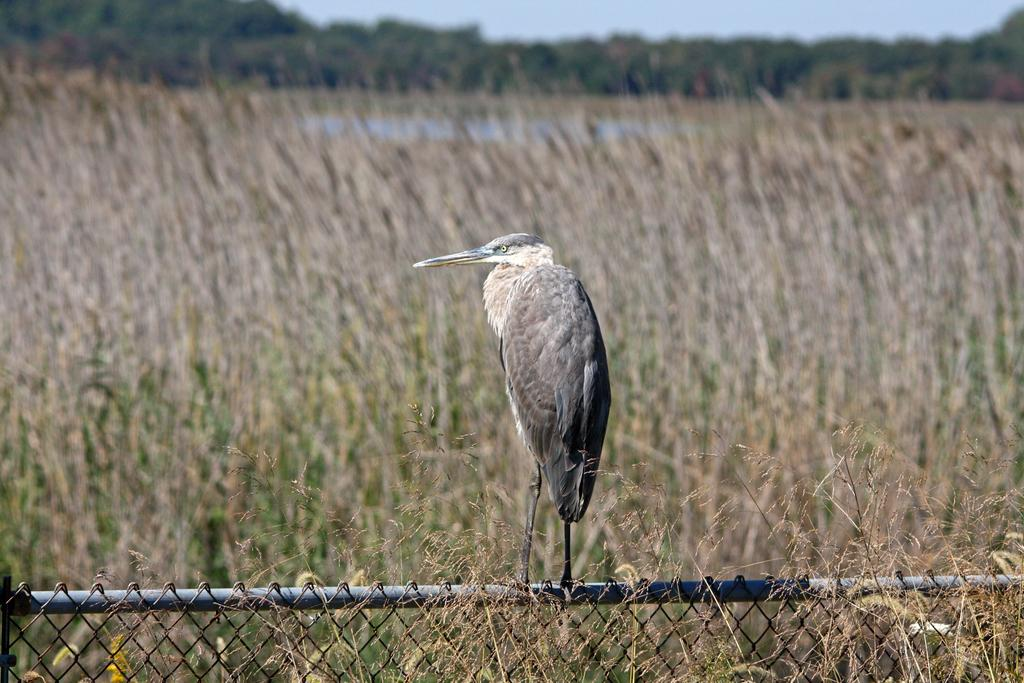What can be seen in the background of the image? There is a sky and trees visible in the background of the image. What type of landscape is present in the image? There is a field in the image. What is at the bottom portion of the image? There is a fence at the bottom portion of the image. What animal can be seen in the image? There is a bird on a pole in the image. What type of pear is being used as a mitten in the image? There is no pear or mitten present in the image. What invention is being demonstrated by the bird on the pole in the image? There is no invention being demonstrated by the bird on the pole in the image. 